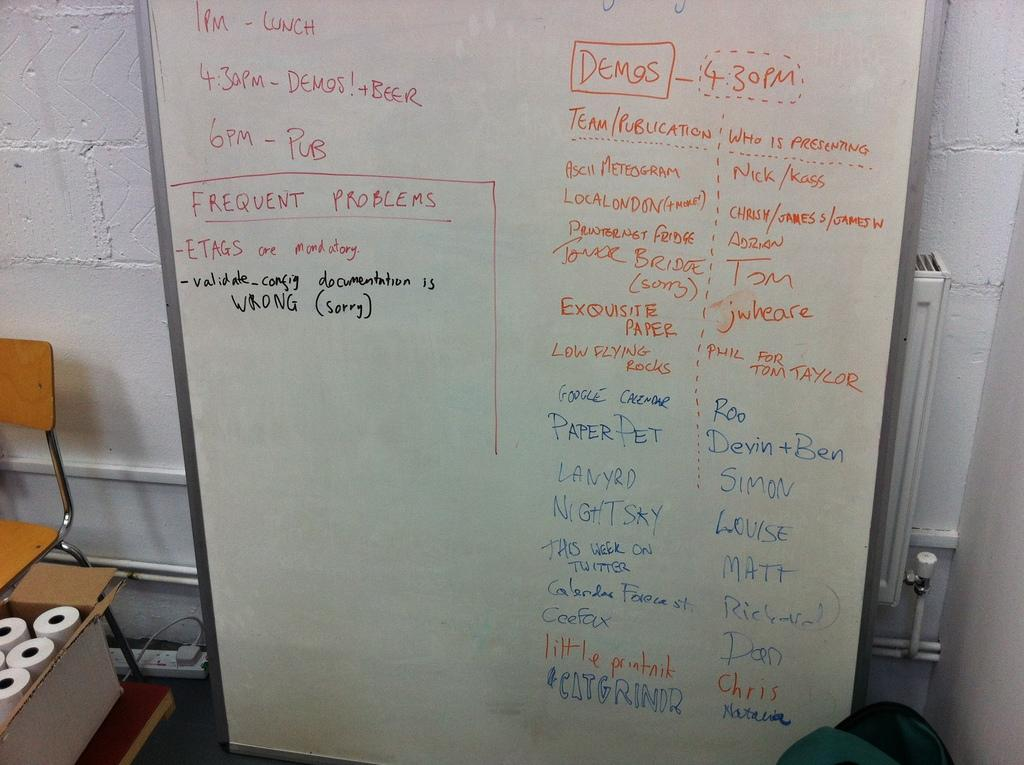<image>
Provide a brief description of the given image. A list of teams and presenters is on a dry erase board. 